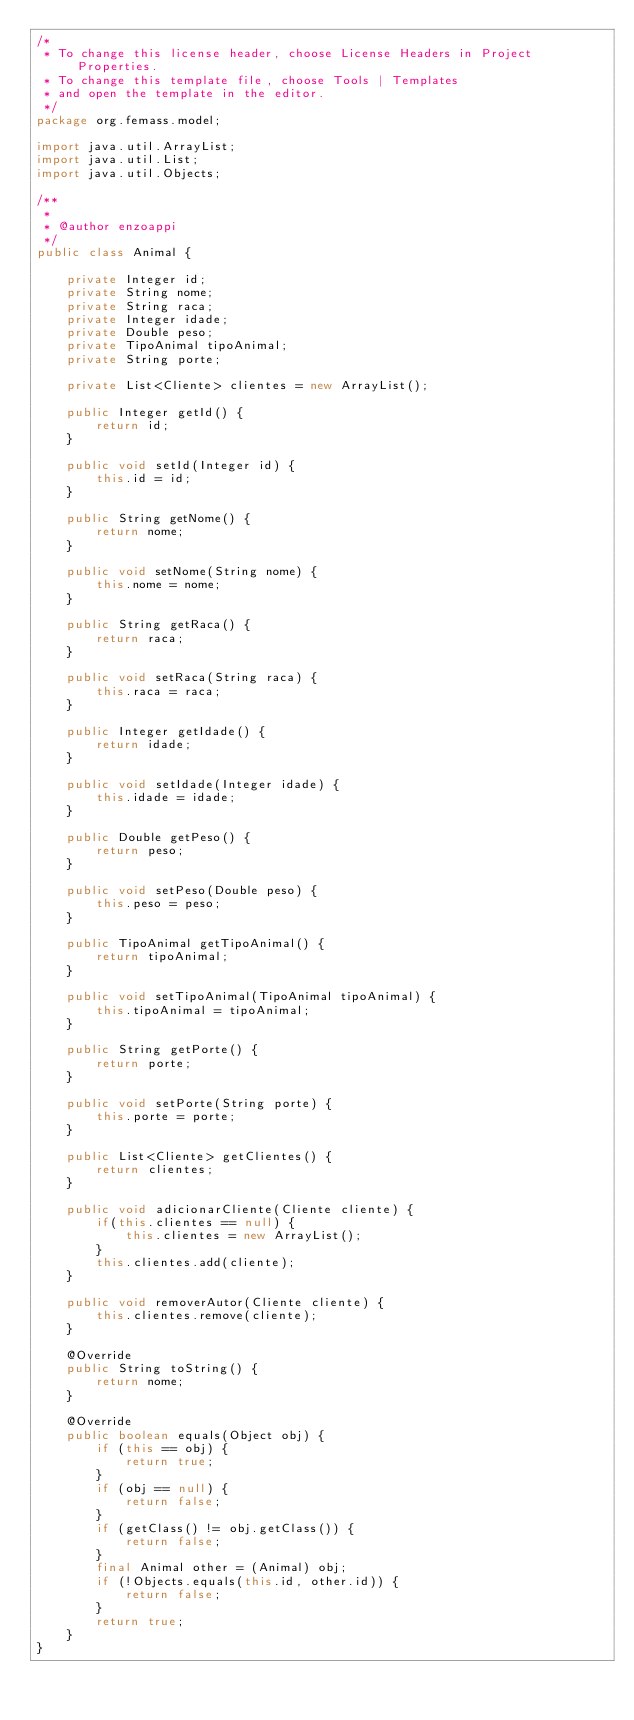Convert code to text. <code><loc_0><loc_0><loc_500><loc_500><_Java_>/*
 * To change this license header, choose License Headers in Project Properties.
 * To change this template file, choose Tools | Templates
 * and open the template in the editor.
 */
package org.femass.model;

import java.util.ArrayList;
import java.util.List;
import java.util.Objects;

/**
 *
 * @author enzoappi
 */
public class Animal {
    
    private Integer id;
    private String nome;
    private String raca;
    private Integer idade;
    private Double peso;
    private TipoAnimal tipoAnimal;
    private String porte;
    
    private List<Cliente> clientes = new ArrayList();

    public Integer getId() {
        return id;
    }

    public void setId(Integer id) {
        this.id = id;
    }

    public String getNome() {
        return nome;
    }

    public void setNome(String nome) {
        this.nome = nome;
    }

    public String getRaca() {
        return raca;
    }

    public void setRaca(String raca) {
        this.raca = raca;
    }

    public Integer getIdade() {
        return idade;
    }

    public void setIdade(Integer idade) {
        this.idade = idade;
    }

    public Double getPeso() {
        return peso;
    }

    public void setPeso(Double peso) {
        this.peso = peso;
    }

    public TipoAnimal getTipoAnimal() {
        return tipoAnimal;
    }

    public void setTipoAnimal(TipoAnimal tipoAnimal) {
        this.tipoAnimal = tipoAnimal;
    }

    public String getPorte() {
        return porte;
    }

    public void setPorte(String porte) {
        this.porte = porte;
    }
    
    public List<Cliente> getClientes() {
        return clientes;
    }

    public void adicionarCliente(Cliente cliente) {
        if(this.clientes == null) {
            this.clientes = new ArrayList();
        }
        this.clientes.add(cliente);
    }
    
    public void removerAutor(Cliente cliente) {
        this.clientes.remove(cliente);
    }

    @Override
    public String toString() {
        return nome;
    }

    @Override
    public boolean equals(Object obj) {
        if (this == obj) {
            return true;
        }
        if (obj == null) {
            return false;
        }
        if (getClass() != obj.getClass()) {
            return false;
        }
        final Animal other = (Animal) obj;
        if (!Objects.equals(this.id, other.id)) {
            return false;
        }
        return true;
    }
}
</code> 